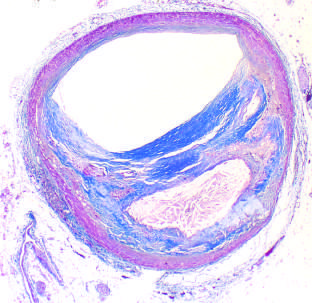s the lumen moderately narrowed by this eccentric lesion, which leaves part of the vessel wall unaffected?
Answer the question using a single word or phrase. Yes 